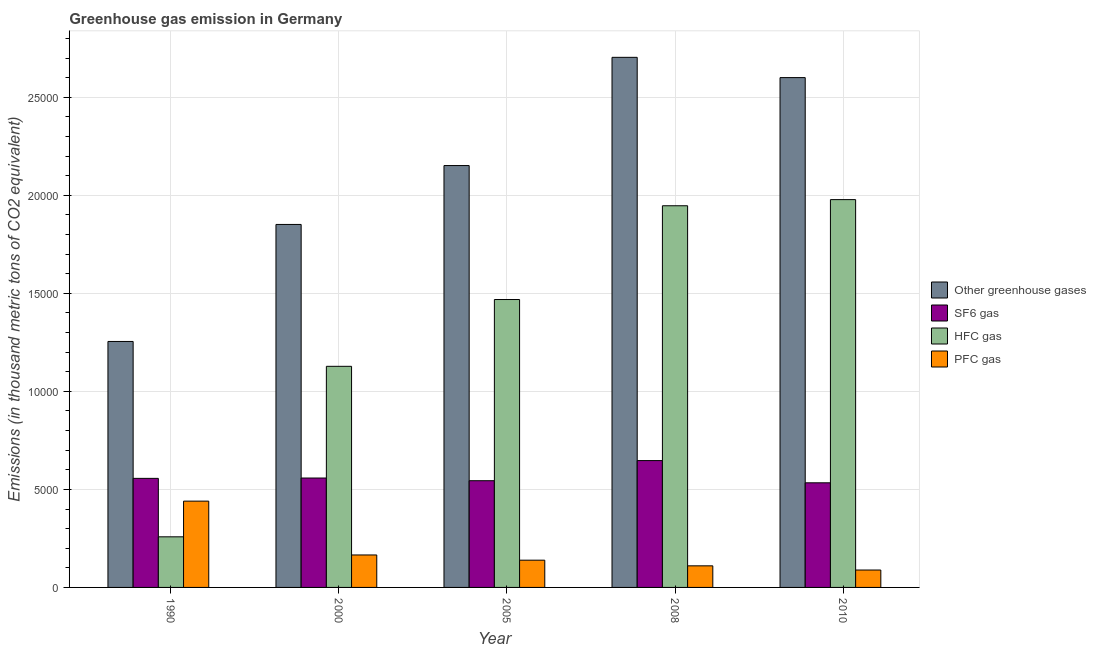How many different coloured bars are there?
Make the answer very short. 4. How many groups of bars are there?
Offer a terse response. 5. Are the number of bars per tick equal to the number of legend labels?
Provide a short and direct response. Yes. What is the emission of greenhouse gases in 2008?
Offer a terse response. 2.70e+04. Across all years, what is the maximum emission of pfc gas?
Keep it short and to the point. 4401.3. Across all years, what is the minimum emission of greenhouse gases?
Give a very brief answer. 1.25e+04. In which year was the emission of pfc gas maximum?
Give a very brief answer. 1990. What is the total emission of hfc gas in the graph?
Your answer should be very brief. 6.78e+04. What is the difference between the emission of sf6 gas in 2000 and that in 2005?
Make the answer very short. 137.2. What is the difference between the emission of greenhouse gases in 2010 and the emission of sf6 gas in 1990?
Give a very brief answer. 1.35e+04. What is the average emission of pfc gas per year?
Ensure brevity in your answer.  1887.26. What is the ratio of the emission of pfc gas in 1990 to that in 2008?
Your answer should be compact. 4. Is the difference between the emission of sf6 gas in 2000 and 2010 greater than the difference between the emission of hfc gas in 2000 and 2010?
Your answer should be compact. No. What is the difference between the highest and the second highest emission of sf6 gas?
Offer a very short reply. 889.2. What is the difference between the highest and the lowest emission of sf6 gas?
Your answer should be compact. 1133.6. In how many years, is the emission of hfc gas greater than the average emission of hfc gas taken over all years?
Ensure brevity in your answer.  3. Is the sum of the emission of greenhouse gases in 1990 and 2008 greater than the maximum emission of pfc gas across all years?
Ensure brevity in your answer.  Yes. What does the 2nd bar from the left in 2005 represents?
Your answer should be very brief. SF6 gas. What does the 2nd bar from the right in 1990 represents?
Provide a succinct answer. HFC gas. Is it the case that in every year, the sum of the emission of greenhouse gases and emission of sf6 gas is greater than the emission of hfc gas?
Your answer should be very brief. Yes. How many years are there in the graph?
Your response must be concise. 5. What is the difference between two consecutive major ticks on the Y-axis?
Your response must be concise. 5000. Are the values on the major ticks of Y-axis written in scientific E-notation?
Provide a short and direct response. No. Does the graph contain any zero values?
Give a very brief answer. No. How many legend labels are there?
Your response must be concise. 4. What is the title of the graph?
Your response must be concise. Greenhouse gas emission in Germany. Does "Tertiary schools" appear as one of the legend labels in the graph?
Give a very brief answer. No. What is the label or title of the X-axis?
Offer a terse response. Year. What is the label or title of the Y-axis?
Your answer should be very brief. Emissions (in thousand metric tons of CO2 equivalent). What is the Emissions (in thousand metric tons of CO2 equivalent) of Other greenhouse gases in 1990?
Keep it short and to the point. 1.25e+04. What is the Emissions (in thousand metric tons of CO2 equivalent) in SF6 gas in 1990?
Give a very brief answer. 5562.9. What is the Emissions (in thousand metric tons of CO2 equivalent) of HFC gas in 1990?
Offer a very short reply. 2581.5. What is the Emissions (in thousand metric tons of CO2 equivalent) in PFC gas in 1990?
Give a very brief answer. 4401.3. What is the Emissions (in thousand metric tons of CO2 equivalent) in Other greenhouse gases in 2000?
Provide a short and direct response. 1.85e+04. What is the Emissions (in thousand metric tons of CO2 equivalent) of SF6 gas in 2000?
Give a very brief answer. 5580.4. What is the Emissions (in thousand metric tons of CO2 equivalent) in HFC gas in 2000?
Offer a very short reply. 1.13e+04. What is the Emissions (in thousand metric tons of CO2 equivalent) of PFC gas in 2000?
Offer a very short reply. 1655.9. What is the Emissions (in thousand metric tons of CO2 equivalent) in Other greenhouse gases in 2005?
Offer a terse response. 2.15e+04. What is the Emissions (in thousand metric tons of CO2 equivalent) of SF6 gas in 2005?
Provide a short and direct response. 5443.2. What is the Emissions (in thousand metric tons of CO2 equivalent) in HFC gas in 2005?
Make the answer very short. 1.47e+04. What is the Emissions (in thousand metric tons of CO2 equivalent) in PFC gas in 2005?
Your response must be concise. 1389.7. What is the Emissions (in thousand metric tons of CO2 equivalent) in Other greenhouse gases in 2008?
Your answer should be very brief. 2.70e+04. What is the Emissions (in thousand metric tons of CO2 equivalent) in SF6 gas in 2008?
Ensure brevity in your answer.  6469.6. What is the Emissions (in thousand metric tons of CO2 equivalent) of HFC gas in 2008?
Offer a very short reply. 1.95e+04. What is the Emissions (in thousand metric tons of CO2 equivalent) of PFC gas in 2008?
Your response must be concise. 1101.4. What is the Emissions (in thousand metric tons of CO2 equivalent) of Other greenhouse gases in 2010?
Keep it short and to the point. 2.60e+04. What is the Emissions (in thousand metric tons of CO2 equivalent) in SF6 gas in 2010?
Keep it short and to the point. 5336. What is the Emissions (in thousand metric tons of CO2 equivalent) of HFC gas in 2010?
Offer a very short reply. 1.98e+04. What is the Emissions (in thousand metric tons of CO2 equivalent) of PFC gas in 2010?
Make the answer very short. 888. Across all years, what is the maximum Emissions (in thousand metric tons of CO2 equivalent) of Other greenhouse gases?
Ensure brevity in your answer.  2.70e+04. Across all years, what is the maximum Emissions (in thousand metric tons of CO2 equivalent) of SF6 gas?
Your answer should be very brief. 6469.6. Across all years, what is the maximum Emissions (in thousand metric tons of CO2 equivalent) of HFC gas?
Provide a short and direct response. 1.98e+04. Across all years, what is the maximum Emissions (in thousand metric tons of CO2 equivalent) of PFC gas?
Offer a very short reply. 4401.3. Across all years, what is the minimum Emissions (in thousand metric tons of CO2 equivalent) of Other greenhouse gases?
Keep it short and to the point. 1.25e+04. Across all years, what is the minimum Emissions (in thousand metric tons of CO2 equivalent) in SF6 gas?
Offer a terse response. 5336. Across all years, what is the minimum Emissions (in thousand metric tons of CO2 equivalent) of HFC gas?
Make the answer very short. 2581.5. Across all years, what is the minimum Emissions (in thousand metric tons of CO2 equivalent) in PFC gas?
Keep it short and to the point. 888. What is the total Emissions (in thousand metric tons of CO2 equivalent) in Other greenhouse gases in the graph?
Provide a short and direct response. 1.06e+05. What is the total Emissions (in thousand metric tons of CO2 equivalent) of SF6 gas in the graph?
Ensure brevity in your answer.  2.84e+04. What is the total Emissions (in thousand metric tons of CO2 equivalent) in HFC gas in the graph?
Your answer should be compact. 6.78e+04. What is the total Emissions (in thousand metric tons of CO2 equivalent) of PFC gas in the graph?
Keep it short and to the point. 9436.3. What is the difference between the Emissions (in thousand metric tons of CO2 equivalent) of Other greenhouse gases in 1990 and that in 2000?
Give a very brief answer. -5968.2. What is the difference between the Emissions (in thousand metric tons of CO2 equivalent) of SF6 gas in 1990 and that in 2000?
Your answer should be compact. -17.5. What is the difference between the Emissions (in thousand metric tons of CO2 equivalent) in HFC gas in 1990 and that in 2000?
Your answer should be compact. -8696.1. What is the difference between the Emissions (in thousand metric tons of CO2 equivalent) of PFC gas in 1990 and that in 2000?
Provide a short and direct response. 2745.4. What is the difference between the Emissions (in thousand metric tons of CO2 equivalent) of Other greenhouse gases in 1990 and that in 2005?
Your answer should be compact. -8971.8. What is the difference between the Emissions (in thousand metric tons of CO2 equivalent) in SF6 gas in 1990 and that in 2005?
Provide a succinct answer. 119.7. What is the difference between the Emissions (in thousand metric tons of CO2 equivalent) of HFC gas in 1990 and that in 2005?
Offer a terse response. -1.21e+04. What is the difference between the Emissions (in thousand metric tons of CO2 equivalent) in PFC gas in 1990 and that in 2005?
Offer a terse response. 3011.6. What is the difference between the Emissions (in thousand metric tons of CO2 equivalent) of Other greenhouse gases in 1990 and that in 2008?
Keep it short and to the point. -1.45e+04. What is the difference between the Emissions (in thousand metric tons of CO2 equivalent) of SF6 gas in 1990 and that in 2008?
Provide a succinct answer. -906.7. What is the difference between the Emissions (in thousand metric tons of CO2 equivalent) in HFC gas in 1990 and that in 2008?
Offer a very short reply. -1.69e+04. What is the difference between the Emissions (in thousand metric tons of CO2 equivalent) of PFC gas in 1990 and that in 2008?
Ensure brevity in your answer.  3299.9. What is the difference between the Emissions (in thousand metric tons of CO2 equivalent) in Other greenhouse gases in 1990 and that in 2010?
Ensure brevity in your answer.  -1.35e+04. What is the difference between the Emissions (in thousand metric tons of CO2 equivalent) of SF6 gas in 1990 and that in 2010?
Offer a very short reply. 226.9. What is the difference between the Emissions (in thousand metric tons of CO2 equivalent) of HFC gas in 1990 and that in 2010?
Offer a very short reply. -1.72e+04. What is the difference between the Emissions (in thousand metric tons of CO2 equivalent) in PFC gas in 1990 and that in 2010?
Your answer should be compact. 3513.3. What is the difference between the Emissions (in thousand metric tons of CO2 equivalent) of Other greenhouse gases in 2000 and that in 2005?
Your answer should be compact. -3003.6. What is the difference between the Emissions (in thousand metric tons of CO2 equivalent) in SF6 gas in 2000 and that in 2005?
Provide a short and direct response. 137.2. What is the difference between the Emissions (in thousand metric tons of CO2 equivalent) of HFC gas in 2000 and that in 2005?
Your answer should be compact. -3407. What is the difference between the Emissions (in thousand metric tons of CO2 equivalent) of PFC gas in 2000 and that in 2005?
Provide a succinct answer. 266.2. What is the difference between the Emissions (in thousand metric tons of CO2 equivalent) of Other greenhouse gases in 2000 and that in 2008?
Your response must be concise. -8523.9. What is the difference between the Emissions (in thousand metric tons of CO2 equivalent) in SF6 gas in 2000 and that in 2008?
Your response must be concise. -889.2. What is the difference between the Emissions (in thousand metric tons of CO2 equivalent) of HFC gas in 2000 and that in 2008?
Your answer should be compact. -8189.2. What is the difference between the Emissions (in thousand metric tons of CO2 equivalent) in PFC gas in 2000 and that in 2008?
Offer a very short reply. 554.5. What is the difference between the Emissions (in thousand metric tons of CO2 equivalent) of Other greenhouse gases in 2000 and that in 2010?
Your answer should be compact. -7490.1. What is the difference between the Emissions (in thousand metric tons of CO2 equivalent) of SF6 gas in 2000 and that in 2010?
Your answer should be very brief. 244.4. What is the difference between the Emissions (in thousand metric tons of CO2 equivalent) in HFC gas in 2000 and that in 2010?
Your answer should be compact. -8502.4. What is the difference between the Emissions (in thousand metric tons of CO2 equivalent) of PFC gas in 2000 and that in 2010?
Offer a terse response. 767.9. What is the difference between the Emissions (in thousand metric tons of CO2 equivalent) of Other greenhouse gases in 2005 and that in 2008?
Give a very brief answer. -5520.3. What is the difference between the Emissions (in thousand metric tons of CO2 equivalent) in SF6 gas in 2005 and that in 2008?
Make the answer very short. -1026.4. What is the difference between the Emissions (in thousand metric tons of CO2 equivalent) of HFC gas in 2005 and that in 2008?
Keep it short and to the point. -4782.2. What is the difference between the Emissions (in thousand metric tons of CO2 equivalent) in PFC gas in 2005 and that in 2008?
Ensure brevity in your answer.  288.3. What is the difference between the Emissions (in thousand metric tons of CO2 equivalent) in Other greenhouse gases in 2005 and that in 2010?
Offer a terse response. -4486.5. What is the difference between the Emissions (in thousand metric tons of CO2 equivalent) in SF6 gas in 2005 and that in 2010?
Ensure brevity in your answer.  107.2. What is the difference between the Emissions (in thousand metric tons of CO2 equivalent) of HFC gas in 2005 and that in 2010?
Your response must be concise. -5095.4. What is the difference between the Emissions (in thousand metric tons of CO2 equivalent) in PFC gas in 2005 and that in 2010?
Give a very brief answer. 501.7. What is the difference between the Emissions (in thousand metric tons of CO2 equivalent) of Other greenhouse gases in 2008 and that in 2010?
Your response must be concise. 1033.8. What is the difference between the Emissions (in thousand metric tons of CO2 equivalent) of SF6 gas in 2008 and that in 2010?
Offer a terse response. 1133.6. What is the difference between the Emissions (in thousand metric tons of CO2 equivalent) of HFC gas in 2008 and that in 2010?
Make the answer very short. -313.2. What is the difference between the Emissions (in thousand metric tons of CO2 equivalent) of PFC gas in 2008 and that in 2010?
Offer a terse response. 213.4. What is the difference between the Emissions (in thousand metric tons of CO2 equivalent) of Other greenhouse gases in 1990 and the Emissions (in thousand metric tons of CO2 equivalent) of SF6 gas in 2000?
Make the answer very short. 6965.3. What is the difference between the Emissions (in thousand metric tons of CO2 equivalent) of Other greenhouse gases in 1990 and the Emissions (in thousand metric tons of CO2 equivalent) of HFC gas in 2000?
Provide a succinct answer. 1268.1. What is the difference between the Emissions (in thousand metric tons of CO2 equivalent) of Other greenhouse gases in 1990 and the Emissions (in thousand metric tons of CO2 equivalent) of PFC gas in 2000?
Keep it short and to the point. 1.09e+04. What is the difference between the Emissions (in thousand metric tons of CO2 equivalent) of SF6 gas in 1990 and the Emissions (in thousand metric tons of CO2 equivalent) of HFC gas in 2000?
Provide a short and direct response. -5714.7. What is the difference between the Emissions (in thousand metric tons of CO2 equivalent) of SF6 gas in 1990 and the Emissions (in thousand metric tons of CO2 equivalent) of PFC gas in 2000?
Provide a succinct answer. 3907. What is the difference between the Emissions (in thousand metric tons of CO2 equivalent) in HFC gas in 1990 and the Emissions (in thousand metric tons of CO2 equivalent) in PFC gas in 2000?
Offer a terse response. 925.6. What is the difference between the Emissions (in thousand metric tons of CO2 equivalent) in Other greenhouse gases in 1990 and the Emissions (in thousand metric tons of CO2 equivalent) in SF6 gas in 2005?
Make the answer very short. 7102.5. What is the difference between the Emissions (in thousand metric tons of CO2 equivalent) in Other greenhouse gases in 1990 and the Emissions (in thousand metric tons of CO2 equivalent) in HFC gas in 2005?
Offer a terse response. -2138.9. What is the difference between the Emissions (in thousand metric tons of CO2 equivalent) of Other greenhouse gases in 1990 and the Emissions (in thousand metric tons of CO2 equivalent) of PFC gas in 2005?
Offer a very short reply. 1.12e+04. What is the difference between the Emissions (in thousand metric tons of CO2 equivalent) of SF6 gas in 1990 and the Emissions (in thousand metric tons of CO2 equivalent) of HFC gas in 2005?
Offer a terse response. -9121.7. What is the difference between the Emissions (in thousand metric tons of CO2 equivalent) in SF6 gas in 1990 and the Emissions (in thousand metric tons of CO2 equivalent) in PFC gas in 2005?
Ensure brevity in your answer.  4173.2. What is the difference between the Emissions (in thousand metric tons of CO2 equivalent) in HFC gas in 1990 and the Emissions (in thousand metric tons of CO2 equivalent) in PFC gas in 2005?
Offer a very short reply. 1191.8. What is the difference between the Emissions (in thousand metric tons of CO2 equivalent) in Other greenhouse gases in 1990 and the Emissions (in thousand metric tons of CO2 equivalent) in SF6 gas in 2008?
Make the answer very short. 6076.1. What is the difference between the Emissions (in thousand metric tons of CO2 equivalent) in Other greenhouse gases in 1990 and the Emissions (in thousand metric tons of CO2 equivalent) in HFC gas in 2008?
Ensure brevity in your answer.  -6921.1. What is the difference between the Emissions (in thousand metric tons of CO2 equivalent) of Other greenhouse gases in 1990 and the Emissions (in thousand metric tons of CO2 equivalent) of PFC gas in 2008?
Keep it short and to the point. 1.14e+04. What is the difference between the Emissions (in thousand metric tons of CO2 equivalent) of SF6 gas in 1990 and the Emissions (in thousand metric tons of CO2 equivalent) of HFC gas in 2008?
Give a very brief answer. -1.39e+04. What is the difference between the Emissions (in thousand metric tons of CO2 equivalent) in SF6 gas in 1990 and the Emissions (in thousand metric tons of CO2 equivalent) in PFC gas in 2008?
Offer a terse response. 4461.5. What is the difference between the Emissions (in thousand metric tons of CO2 equivalent) in HFC gas in 1990 and the Emissions (in thousand metric tons of CO2 equivalent) in PFC gas in 2008?
Keep it short and to the point. 1480.1. What is the difference between the Emissions (in thousand metric tons of CO2 equivalent) in Other greenhouse gases in 1990 and the Emissions (in thousand metric tons of CO2 equivalent) in SF6 gas in 2010?
Keep it short and to the point. 7209.7. What is the difference between the Emissions (in thousand metric tons of CO2 equivalent) in Other greenhouse gases in 1990 and the Emissions (in thousand metric tons of CO2 equivalent) in HFC gas in 2010?
Your response must be concise. -7234.3. What is the difference between the Emissions (in thousand metric tons of CO2 equivalent) of Other greenhouse gases in 1990 and the Emissions (in thousand metric tons of CO2 equivalent) of PFC gas in 2010?
Provide a succinct answer. 1.17e+04. What is the difference between the Emissions (in thousand metric tons of CO2 equivalent) of SF6 gas in 1990 and the Emissions (in thousand metric tons of CO2 equivalent) of HFC gas in 2010?
Your response must be concise. -1.42e+04. What is the difference between the Emissions (in thousand metric tons of CO2 equivalent) in SF6 gas in 1990 and the Emissions (in thousand metric tons of CO2 equivalent) in PFC gas in 2010?
Provide a short and direct response. 4674.9. What is the difference between the Emissions (in thousand metric tons of CO2 equivalent) of HFC gas in 1990 and the Emissions (in thousand metric tons of CO2 equivalent) of PFC gas in 2010?
Keep it short and to the point. 1693.5. What is the difference between the Emissions (in thousand metric tons of CO2 equivalent) of Other greenhouse gases in 2000 and the Emissions (in thousand metric tons of CO2 equivalent) of SF6 gas in 2005?
Make the answer very short. 1.31e+04. What is the difference between the Emissions (in thousand metric tons of CO2 equivalent) of Other greenhouse gases in 2000 and the Emissions (in thousand metric tons of CO2 equivalent) of HFC gas in 2005?
Provide a short and direct response. 3829.3. What is the difference between the Emissions (in thousand metric tons of CO2 equivalent) of Other greenhouse gases in 2000 and the Emissions (in thousand metric tons of CO2 equivalent) of PFC gas in 2005?
Make the answer very short. 1.71e+04. What is the difference between the Emissions (in thousand metric tons of CO2 equivalent) of SF6 gas in 2000 and the Emissions (in thousand metric tons of CO2 equivalent) of HFC gas in 2005?
Keep it short and to the point. -9104.2. What is the difference between the Emissions (in thousand metric tons of CO2 equivalent) in SF6 gas in 2000 and the Emissions (in thousand metric tons of CO2 equivalent) in PFC gas in 2005?
Keep it short and to the point. 4190.7. What is the difference between the Emissions (in thousand metric tons of CO2 equivalent) in HFC gas in 2000 and the Emissions (in thousand metric tons of CO2 equivalent) in PFC gas in 2005?
Provide a succinct answer. 9887.9. What is the difference between the Emissions (in thousand metric tons of CO2 equivalent) of Other greenhouse gases in 2000 and the Emissions (in thousand metric tons of CO2 equivalent) of SF6 gas in 2008?
Your answer should be compact. 1.20e+04. What is the difference between the Emissions (in thousand metric tons of CO2 equivalent) in Other greenhouse gases in 2000 and the Emissions (in thousand metric tons of CO2 equivalent) in HFC gas in 2008?
Your answer should be very brief. -952.9. What is the difference between the Emissions (in thousand metric tons of CO2 equivalent) of Other greenhouse gases in 2000 and the Emissions (in thousand metric tons of CO2 equivalent) of PFC gas in 2008?
Give a very brief answer. 1.74e+04. What is the difference between the Emissions (in thousand metric tons of CO2 equivalent) of SF6 gas in 2000 and the Emissions (in thousand metric tons of CO2 equivalent) of HFC gas in 2008?
Offer a terse response. -1.39e+04. What is the difference between the Emissions (in thousand metric tons of CO2 equivalent) of SF6 gas in 2000 and the Emissions (in thousand metric tons of CO2 equivalent) of PFC gas in 2008?
Provide a succinct answer. 4479. What is the difference between the Emissions (in thousand metric tons of CO2 equivalent) in HFC gas in 2000 and the Emissions (in thousand metric tons of CO2 equivalent) in PFC gas in 2008?
Ensure brevity in your answer.  1.02e+04. What is the difference between the Emissions (in thousand metric tons of CO2 equivalent) in Other greenhouse gases in 2000 and the Emissions (in thousand metric tons of CO2 equivalent) in SF6 gas in 2010?
Your answer should be very brief. 1.32e+04. What is the difference between the Emissions (in thousand metric tons of CO2 equivalent) of Other greenhouse gases in 2000 and the Emissions (in thousand metric tons of CO2 equivalent) of HFC gas in 2010?
Keep it short and to the point. -1266.1. What is the difference between the Emissions (in thousand metric tons of CO2 equivalent) in Other greenhouse gases in 2000 and the Emissions (in thousand metric tons of CO2 equivalent) in PFC gas in 2010?
Your response must be concise. 1.76e+04. What is the difference between the Emissions (in thousand metric tons of CO2 equivalent) in SF6 gas in 2000 and the Emissions (in thousand metric tons of CO2 equivalent) in HFC gas in 2010?
Give a very brief answer. -1.42e+04. What is the difference between the Emissions (in thousand metric tons of CO2 equivalent) in SF6 gas in 2000 and the Emissions (in thousand metric tons of CO2 equivalent) in PFC gas in 2010?
Your answer should be compact. 4692.4. What is the difference between the Emissions (in thousand metric tons of CO2 equivalent) of HFC gas in 2000 and the Emissions (in thousand metric tons of CO2 equivalent) of PFC gas in 2010?
Provide a short and direct response. 1.04e+04. What is the difference between the Emissions (in thousand metric tons of CO2 equivalent) of Other greenhouse gases in 2005 and the Emissions (in thousand metric tons of CO2 equivalent) of SF6 gas in 2008?
Make the answer very short. 1.50e+04. What is the difference between the Emissions (in thousand metric tons of CO2 equivalent) in Other greenhouse gases in 2005 and the Emissions (in thousand metric tons of CO2 equivalent) in HFC gas in 2008?
Provide a short and direct response. 2050.7. What is the difference between the Emissions (in thousand metric tons of CO2 equivalent) in Other greenhouse gases in 2005 and the Emissions (in thousand metric tons of CO2 equivalent) in PFC gas in 2008?
Provide a succinct answer. 2.04e+04. What is the difference between the Emissions (in thousand metric tons of CO2 equivalent) in SF6 gas in 2005 and the Emissions (in thousand metric tons of CO2 equivalent) in HFC gas in 2008?
Make the answer very short. -1.40e+04. What is the difference between the Emissions (in thousand metric tons of CO2 equivalent) in SF6 gas in 2005 and the Emissions (in thousand metric tons of CO2 equivalent) in PFC gas in 2008?
Your response must be concise. 4341.8. What is the difference between the Emissions (in thousand metric tons of CO2 equivalent) in HFC gas in 2005 and the Emissions (in thousand metric tons of CO2 equivalent) in PFC gas in 2008?
Ensure brevity in your answer.  1.36e+04. What is the difference between the Emissions (in thousand metric tons of CO2 equivalent) in Other greenhouse gases in 2005 and the Emissions (in thousand metric tons of CO2 equivalent) in SF6 gas in 2010?
Your answer should be compact. 1.62e+04. What is the difference between the Emissions (in thousand metric tons of CO2 equivalent) in Other greenhouse gases in 2005 and the Emissions (in thousand metric tons of CO2 equivalent) in HFC gas in 2010?
Offer a terse response. 1737.5. What is the difference between the Emissions (in thousand metric tons of CO2 equivalent) of Other greenhouse gases in 2005 and the Emissions (in thousand metric tons of CO2 equivalent) of PFC gas in 2010?
Offer a terse response. 2.06e+04. What is the difference between the Emissions (in thousand metric tons of CO2 equivalent) of SF6 gas in 2005 and the Emissions (in thousand metric tons of CO2 equivalent) of HFC gas in 2010?
Your answer should be very brief. -1.43e+04. What is the difference between the Emissions (in thousand metric tons of CO2 equivalent) of SF6 gas in 2005 and the Emissions (in thousand metric tons of CO2 equivalent) of PFC gas in 2010?
Make the answer very short. 4555.2. What is the difference between the Emissions (in thousand metric tons of CO2 equivalent) in HFC gas in 2005 and the Emissions (in thousand metric tons of CO2 equivalent) in PFC gas in 2010?
Keep it short and to the point. 1.38e+04. What is the difference between the Emissions (in thousand metric tons of CO2 equivalent) in Other greenhouse gases in 2008 and the Emissions (in thousand metric tons of CO2 equivalent) in SF6 gas in 2010?
Offer a very short reply. 2.17e+04. What is the difference between the Emissions (in thousand metric tons of CO2 equivalent) of Other greenhouse gases in 2008 and the Emissions (in thousand metric tons of CO2 equivalent) of HFC gas in 2010?
Ensure brevity in your answer.  7257.8. What is the difference between the Emissions (in thousand metric tons of CO2 equivalent) in Other greenhouse gases in 2008 and the Emissions (in thousand metric tons of CO2 equivalent) in PFC gas in 2010?
Provide a succinct answer. 2.61e+04. What is the difference between the Emissions (in thousand metric tons of CO2 equivalent) in SF6 gas in 2008 and the Emissions (in thousand metric tons of CO2 equivalent) in HFC gas in 2010?
Provide a succinct answer. -1.33e+04. What is the difference between the Emissions (in thousand metric tons of CO2 equivalent) in SF6 gas in 2008 and the Emissions (in thousand metric tons of CO2 equivalent) in PFC gas in 2010?
Your answer should be compact. 5581.6. What is the difference between the Emissions (in thousand metric tons of CO2 equivalent) of HFC gas in 2008 and the Emissions (in thousand metric tons of CO2 equivalent) of PFC gas in 2010?
Your answer should be very brief. 1.86e+04. What is the average Emissions (in thousand metric tons of CO2 equivalent) of Other greenhouse gases per year?
Your answer should be compact. 2.11e+04. What is the average Emissions (in thousand metric tons of CO2 equivalent) of SF6 gas per year?
Provide a short and direct response. 5678.42. What is the average Emissions (in thousand metric tons of CO2 equivalent) in HFC gas per year?
Your response must be concise. 1.36e+04. What is the average Emissions (in thousand metric tons of CO2 equivalent) in PFC gas per year?
Your answer should be very brief. 1887.26. In the year 1990, what is the difference between the Emissions (in thousand metric tons of CO2 equivalent) of Other greenhouse gases and Emissions (in thousand metric tons of CO2 equivalent) of SF6 gas?
Your answer should be very brief. 6982.8. In the year 1990, what is the difference between the Emissions (in thousand metric tons of CO2 equivalent) in Other greenhouse gases and Emissions (in thousand metric tons of CO2 equivalent) in HFC gas?
Offer a terse response. 9964.2. In the year 1990, what is the difference between the Emissions (in thousand metric tons of CO2 equivalent) in Other greenhouse gases and Emissions (in thousand metric tons of CO2 equivalent) in PFC gas?
Give a very brief answer. 8144.4. In the year 1990, what is the difference between the Emissions (in thousand metric tons of CO2 equivalent) in SF6 gas and Emissions (in thousand metric tons of CO2 equivalent) in HFC gas?
Give a very brief answer. 2981.4. In the year 1990, what is the difference between the Emissions (in thousand metric tons of CO2 equivalent) in SF6 gas and Emissions (in thousand metric tons of CO2 equivalent) in PFC gas?
Offer a terse response. 1161.6. In the year 1990, what is the difference between the Emissions (in thousand metric tons of CO2 equivalent) of HFC gas and Emissions (in thousand metric tons of CO2 equivalent) of PFC gas?
Keep it short and to the point. -1819.8. In the year 2000, what is the difference between the Emissions (in thousand metric tons of CO2 equivalent) of Other greenhouse gases and Emissions (in thousand metric tons of CO2 equivalent) of SF6 gas?
Offer a terse response. 1.29e+04. In the year 2000, what is the difference between the Emissions (in thousand metric tons of CO2 equivalent) of Other greenhouse gases and Emissions (in thousand metric tons of CO2 equivalent) of HFC gas?
Give a very brief answer. 7236.3. In the year 2000, what is the difference between the Emissions (in thousand metric tons of CO2 equivalent) in Other greenhouse gases and Emissions (in thousand metric tons of CO2 equivalent) in PFC gas?
Make the answer very short. 1.69e+04. In the year 2000, what is the difference between the Emissions (in thousand metric tons of CO2 equivalent) in SF6 gas and Emissions (in thousand metric tons of CO2 equivalent) in HFC gas?
Keep it short and to the point. -5697.2. In the year 2000, what is the difference between the Emissions (in thousand metric tons of CO2 equivalent) in SF6 gas and Emissions (in thousand metric tons of CO2 equivalent) in PFC gas?
Provide a short and direct response. 3924.5. In the year 2000, what is the difference between the Emissions (in thousand metric tons of CO2 equivalent) of HFC gas and Emissions (in thousand metric tons of CO2 equivalent) of PFC gas?
Ensure brevity in your answer.  9621.7. In the year 2005, what is the difference between the Emissions (in thousand metric tons of CO2 equivalent) of Other greenhouse gases and Emissions (in thousand metric tons of CO2 equivalent) of SF6 gas?
Offer a very short reply. 1.61e+04. In the year 2005, what is the difference between the Emissions (in thousand metric tons of CO2 equivalent) in Other greenhouse gases and Emissions (in thousand metric tons of CO2 equivalent) in HFC gas?
Ensure brevity in your answer.  6832.9. In the year 2005, what is the difference between the Emissions (in thousand metric tons of CO2 equivalent) in Other greenhouse gases and Emissions (in thousand metric tons of CO2 equivalent) in PFC gas?
Make the answer very short. 2.01e+04. In the year 2005, what is the difference between the Emissions (in thousand metric tons of CO2 equivalent) in SF6 gas and Emissions (in thousand metric tons of CO2 equivalent) in HFC gas?
Your answer should be compact. -9241.4. In the year 2005, what is the difference between the Emissions (in thousand metric tons of CO2 equivalent) of SF6 gas and Emissions (in thousand metric tons of CO2 equivalent) of PFC gas?
Provide a succinct answer. 4053.5. In the year 2005, what is the difference between the Emissions (in thousand metric tons of CO2 equivalent) in HFC gas and Emissions (in thousand metric tons of CO2 equivalent) in PFC gas?
Your response must be concise. 1.33e+04. In the year 2008, what is the difference between the Emissions (in thousand metric tons of CO2 equivalent) of Other greenhouse gases and Emissions (in thousand metric tons of CO2 equivalent) of SF6 gas?
Make the answer very short. 2.06e+04. In the year 2008, what is the difference between the Emissions (in thousand metric tons of CO2 equivalent) of Other greenhouse gases and Emissions (in thousand metric tons of CO2 equivalent) of HFC gas?
Your answer should be compact. 7571. In the year 2008, what is the difference between the Emissions (in thousand metric tons of CO2 equivalent) of Other greenhouse gases and Emissions (in thousand metric tons of CO2 equivalent) of PFC gas?
Provide a short and direct response. 2.59e+04. In the year 2008, what is the difference between the Emissions (in thousand metric tons of CO2 equivalent) of SF6 gas and Emissions (in thousand metric tons of CO2 equivalent) of HFC gas?
Provide a short and direct response. -1.30e+04. In the year 2008, what is the difference between the Emissions (in thousand metric tons of CO2 equivalent) of SF6 gas and Emissions (in thousand metric tons of CO2 equivalent) of PFC gas?
Ensure brevity in your answer.  5368.2. In the year 2008, what is the difference between the Emissions (in thousand metric tons of CO2 equivalent) in HFC gas and Emissions (in thousand metric tons of CO2 equivalent) in PFC gas?
Ensure brevity in your answer.  1.84e+04. In the year 2010, what is the difference between the Emissions (in thousand metric tons of CO2 equivalent) in Other greenhouse gases and Emissions (in thousand metric tons of CO2 equivalent) in SF6 gas?
Provide a succinct answer. 2.07e+04. In the year 2010, what is the difference between the Emissions (in thousand metric tons of CO2 equivalent) of Other greenhouse gases and Emissions (in thousand metric tons of CO2 equivalent) of HFC gas?
Provide a succinct answer. 6224. In the year 2010, what is the difference between the Emissions (in thousand metric tons of CO2 equivalent) in Other greenhouse gases and Emissions (in thousand metric tons of CO2 equivalent) in PFC gas?
Provide a succinct answer. 2.51e+04. In the year 2010, what is the difference between the Emissions (in thousand metric tons of CO2 equivalent) of SF6 gas and Emissions (in thousand metric tons of CO2 equivalent) of HFC gas?
Offer a terse response. -1.44e+04. In the year 2010, what is the difference between the Emissions (in thousand metric tons of CO2 equivalent) in SF6 gas and Emissions (in thousand metric tons of CO2 equivalent) in PFC gas?
Keep it short and to the point. 4448. In the year 2010, what is the difference between the Emissions (in thousand metric tons of CO2 equivalent) of HFC gas and Emissions (in thousand metric tons of CO2 equivalent) of PFC gas?
Offer a terse response. 1.89e+04. What is the ratio of the Emissions (in thousand metric tons of CO2 equivalent) of Other greenhouse gases in 1990 to that in 2000?
Offer a terse response. 0.68. What is the ratio of the Emissions (in thousand metric tons of CO2 equivalent) in SF6 gas in 1990 to that in 2000?
Ensure brevity in your answer.  1. What is the ratio of the Emissions (in thousand metric tons of CO2 equivalent) in HFC gas in 1990 to that in 2000?
Offer a terse response. 0.23. What is the ratio of the Emissions (in thousand metric tons of CO2 equivalent) of PFC gas in 1990 to that in 2000?
Your response must be concise. 2.66. What is the ratio of the Emissions (in thousand metric tons of CO2 equivalent) in Other greenhouse gases in 1990 to that in 2005?
Keep it short and to the point. 0.58. What is the ratio of the Emissions (in thousand metric tons of CO2 equivalent) in SF6 gas in 1990 to that in 2005?
Offer a very short reply. 1.02. What is the ratio of the Emissions (in thousand metric tons of CO2 equivalent) of HFC gas in 1990 to that in 2005?
Make the answer very short. 0.18. What is the ratio of the Emissions (in thousand metric tons of CO2 equivalent) of PFC gas in 1990 to that in 2005?
Give a very brief answer. 3.17. What is the ratio of the Emissions (in thousand metric tons of CO2 equivalent) of Other greenhouse gases in 1990 to that in 2008?
Your answer should be very brief. 0.46. What is the ratio of the Emissions (in thousand metric tons of CO2 equivalent) of SF6 gas in 1990 to that in 2008?
Your response must be concise. 0.86. What is the ratio of the Emissions (in thousand metric tons of CO2 equivalent) in HFC gas in 1990 to that in 2008?
Your response must be concise. 0.13. What is the ratio of the Emissions (in thousand metric tons of CO2 equivalent) in PFC gas in 1990 to that in 2008?
Offer a very short reply. 4. What is the ratio of the Emissions (in thousand metric tons of CO2 equivalent) in Other greenhouse gases in 1990 to that in 2010?
Give a very brief answer. 0.48. What is the ratio of the Emissions (in thousand metric tons of CO2 equivalent) in SF6 gas in 1990 to that in 2010?
Offer a very short reply. 1.04. What is the ratio of the Emissions (in thousand metric tons of CO2 equivalent) in HFC gas in 1990 to that in 2010?
Provide a short and direct response. 0.13. What is the ratio of the Emissions (in thousand metric tons of CO2 equivalent) of PFC gas in 1990 to that in 2010?
Offer a very short reply. 4.96. What is the ratio of the Emissions (in thousand metric tons of CO2 equivalent) of Other greenhouse gases in 2000 to that in 2005?
Your answer should be very brief. 0.86. What is the ratio of the Emissions (in thousand metric tons of CO2 equivalent) of SF6 gas in 2000 to that in 2005?
Provide a short and direct response. 1.03. What is the ratio of the Emissions (in thousand metric tons of CO2 equivalent) of HFC gas in 2000 to that in 2005?
Offer a very short reply. 0.77. What is the ratio of the Emissions (in thousand metric tons of CO2 equivalent) in PFC gas in 2000 to that in 2005?
Your answer should be compact. 1.19. What is the ratio of the Emissions (in thousand metric tons of CO2 equivalent) of Other greenhouse gases in 2000 to that in 2008?
Your response must be concise. 0.68. What is the ratio of the Emissions (in thousand metric tons of CO2 equivalent) of SF6 gas in 2000 to that in 2008?
Offer a very short reply. 0.86. What is the ratio of the Emissions (in thousand metric tons of CO2 equivalent) in HFC gas in 2000 to that in 2008?
Offer a terse response. 0.58. What is the ratio of the Emissions (in thousand metric tons of CO2 equivalent) in PFC gas in 2000 to that in 2008?
Your answer should be compact. 1.5. What is the ratio of the Emissions (in thousand metric tons of CO2 equivalent) of Other greenhouse gases in 2000 to that in 2010?
Keep it short and to the point. 0.71. What is the ratio of the Emissions (in thousand metric tons of CO2 equivalent) of SF6 gas in 2000 to that in 2010?
Give a very brief answer. 1.05. What is the ratio of the Emissions (in thousand metric tons of CO2 equivalent) of HFC gas in 2000 to that in 2010?
Provide a short and direct response. 0.57. What is the ratio of the Emissions (in thousand metric tons of CO2 equivalent) in PFC gas in 2000 to that in 2010?
Offer a terse response. 1.86. What is the ratio of the Emissions (in thousand metric tons of CO2 equivalent) in Other greenhouse gases in 2005 to that in 2008?
Provide a short and direct response. 0.8. What is the ratio of the Emissions (in thousand metric tons of CO2 equivalent) in SF6 gas in 2005 to that in 2008?
Offer a very short reply. 0.84. What is the ratio of the Emissions (in thousand metric tons of CO2 equivalent) of HFC gas in 2005 to that in 2008?
Offer a very short reply. 0.75. What is the ratio of the Emissions (in thousand metric tons of CO2 equivalent) in PFC gas in 2005 to that in 2008?
Make the answer very short. 1.26. What is the ratio of the Emissions (in thousand metric tons of CO2 equivalent) in Other greenhouse gases in 2005 to that in 2010?
Offer a very short reply. 0.83. What is the ratio of the Emissions (in thousand metric tons of CO2 equivalent) in SF6 gas in 2005 to that in 2010?
Provide a short and direct response. 1.02. What is the ratio of the Emissions (in thousand metric tons of CO2 equivalent) of HFC gas in 2005 to that in 2010?
Your answer should be very brief. 0.74. What is the ratio of the Emissions (in thousand metric tons of CO2 equivalent) of PFC gas in 2005 to that in 2010?
Provide a short and direct response. 1.56. What is the ratio of the Emissions (in thousand metric tons of CO2 equivalent) of Other greenhouse gases in 2008 to that in 2010?
Ensure brevity in your answer.  1.04. What is the ratio of the Emissions (in thousand metric tons of CO2 equivalent) in SF6 gas in 2008 to that in 2010?
Offer a very short reply. 1.21. What is the ratio of the Emissions (in thousand metric tons of CO2 equivalent) in HFC gas in 2008 to that in 2010?
Give a very brief answer. 0.98. What is the ratio of the Emissions (in thousand metric tons of CO2 equivalent) of PFC gas in 2008 to that in 2010?
Make the answer very short. 1.24. What is the difference between the highest and the second highest Emissions (in thousand metric tons of CO2 equivalent) of Other greenhouse gases?
Make the answer very short. 1033.8. What is the difference between the highest and the second highest Emissions (in thousand metric tons of CO2 equivalent) of SF6 gas?
Provide a short and direct response. 889.2. What is the difference between the highest and the second highest Emissions (in thousand metric tons of CO2 equivalent) in HFC gas?
Your response must be concise. 313.2. What is the difference between the highest and the second highest Emissions (in thousand metric tons of CO2 equivalent) in PFC gas?
Your answer should be compact. 2745.4. What is the difference between the highest and the lowest Emissions (in thousand metric tons of CO2 equivalent) of Other greenhouse gases?
Provide a succinct answer. 1.45e+04. What is the difference between the highest and the lowest Emissions (in thousand metric tons of CO2 equivalent) in SF6 gas?
Offer a terse response. 1133.6. What is the difference between the highest and the lowest Emissions (in thousand metric tons of CO2 equivalent) in HFC gas?
Give a very brief answer. 1.72e+04. What is the difference between the highest and the lowest Emissions (in thousand metric tons of CO2 equivalent) in PFC gas?
Provide a short and direct response. 3513.3. 